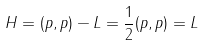Convert formula to latex. <formula><loc_0><loc_0><loc_500><loc_500>H = ( p , p ) - L = \frac { 1 } { 2 } ( p , p ) = L</formula> 